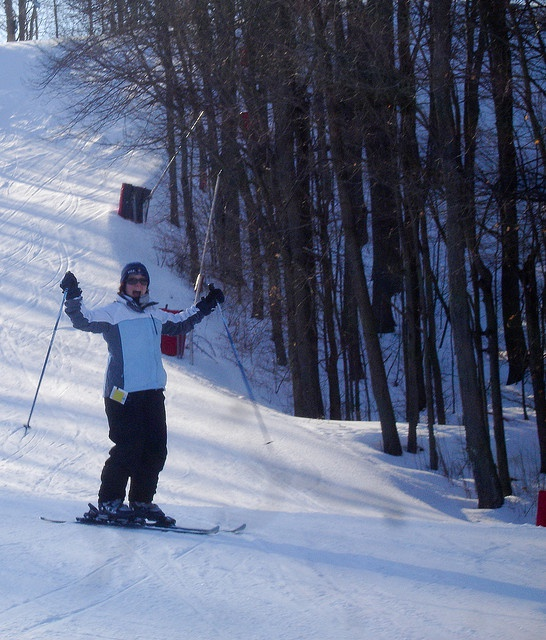Describe the objects in this image and their specific colors. I can see people in lightblue, black, navy, and gray tones and skis in lightblue, gray, navy, darkblue, and darkgray tones in this image. 